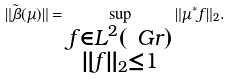<formula> <loc_0><loc_0><loc_500><loc_500>\| \tilde { \beta } ( \mu ) \| = \sup _ { \substack { f \in L ^ { 2 } ( \ G r ) \\ \| f \| _ { 2 } \leq 1 } } \| \mu ^ { * } f \| _ { 2 } .</formula> 